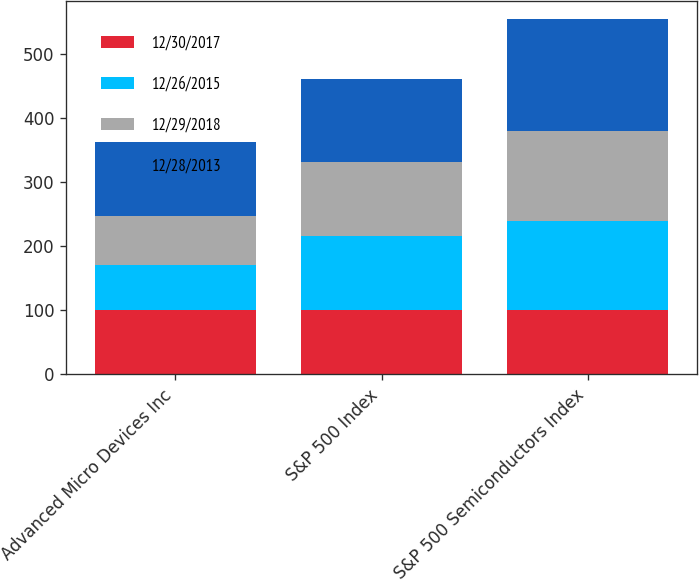<chart> <loc_0><loc_0><loc_500><loc_500><stacked_bar_chart><ecel><fcel>Advanced Micro Devices Inc<fcel>S&P 500 Index<fcel>S&P 500 Semiconductors Index<nl><fcel>12/30/2017<fcel>100<fcel>100<fcel>100<nl><fcel>12/26/2015<fcel>70.11<fcel>115.76<fcel>139.35<nl><fcel>12/29/2018<fcel>77.25<fcel>116.64<fcel>140<nl><fcel>12/28/2013<fcel>115.76<fcel>129.55<fcel>175.9<nl></chart> 